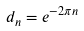<formula> <loc_0><loc_0><loc_500><loc_500>d _ { n } = e ^ { - 2 \pi n }</formula> 